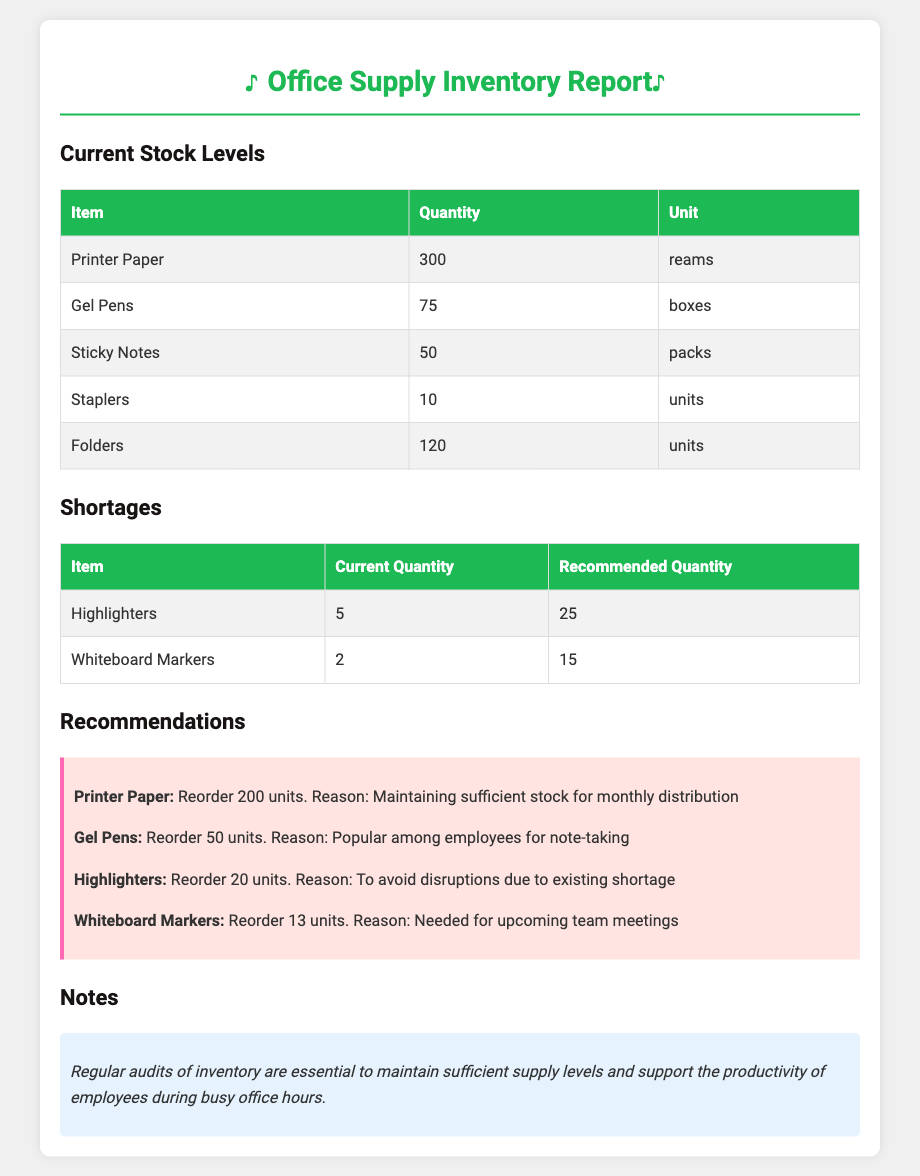What is the current quantity of Printer Paper? The current quantity of Printer Paper is directly stated in the document under Current Stock Levels.
Answer: 300 reams How many Staplers are in stock? The number of Staplers is listed in the Current Stock Levels section of the report.
Answer: 10 units What is the recommended quantity for Highlighters? The recommended quantity for Highlighters is provided in the Shortages section of the document.
Answer: 25 How many Gel Pens should be reordered? The reorder quantity for Gel Pens is mentioned in the Recommendations section.
Answer: 50 units What item has the least quantity currently? The item with the least quantity can be determined by comparing the Current Stock Levels and identifying the smallest number.
Answer: Staplers What reason is given for reordering Highlighters? The document provides reasons for each recommendation in the Recommendations section, specifically for Highlighters.
Answer: To avoid disruptions due to existing shortage What is the total current stock quantity of Sticky Notes? The stock quantity for Sticky Notes is listed under Current Stock Levels and needs to be found there.
Answer: 50 packs What is emphasized as essential for inventory management? The document has a specific note regarding the management of inventory and its importance.
Answer: Regular audits of inventory 